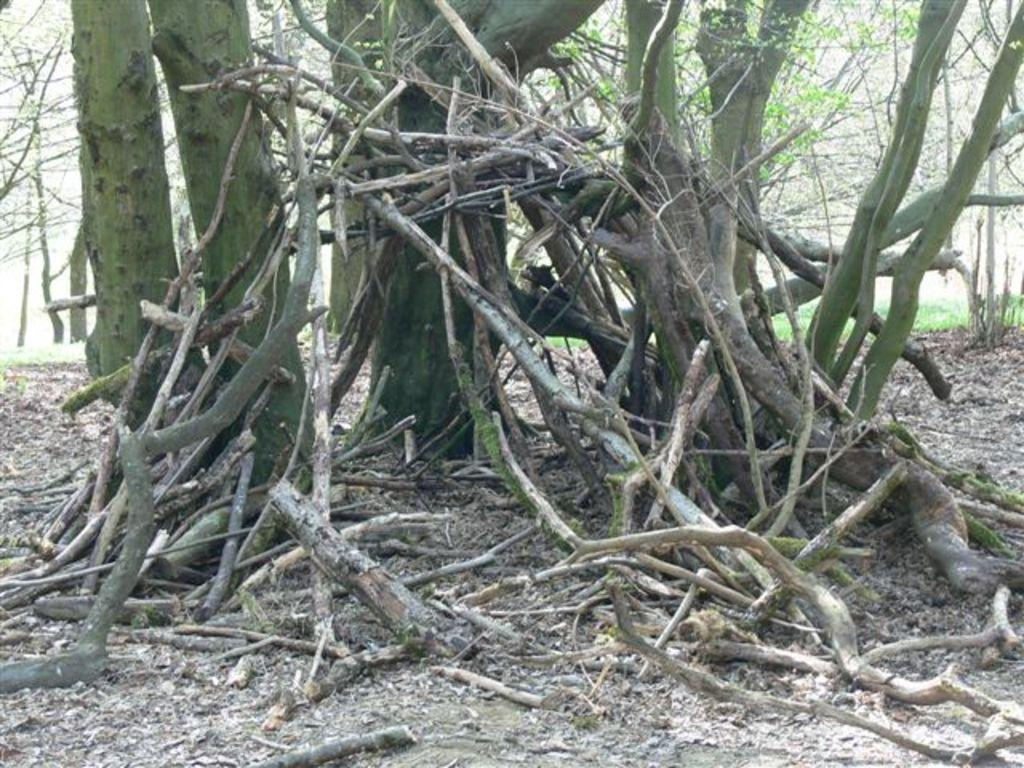What type of natural elements can be seen in the image? There are trees in the image. What is present at the bottom of the image? There is wood sawdust at the bottom of the image. What objects can be seen in the image that are made of wood? There are sticks visible in the image. What type of approval is required to use the amusement park in the image? There is no amusement park present in the image, so the question of approval is not applicable. 